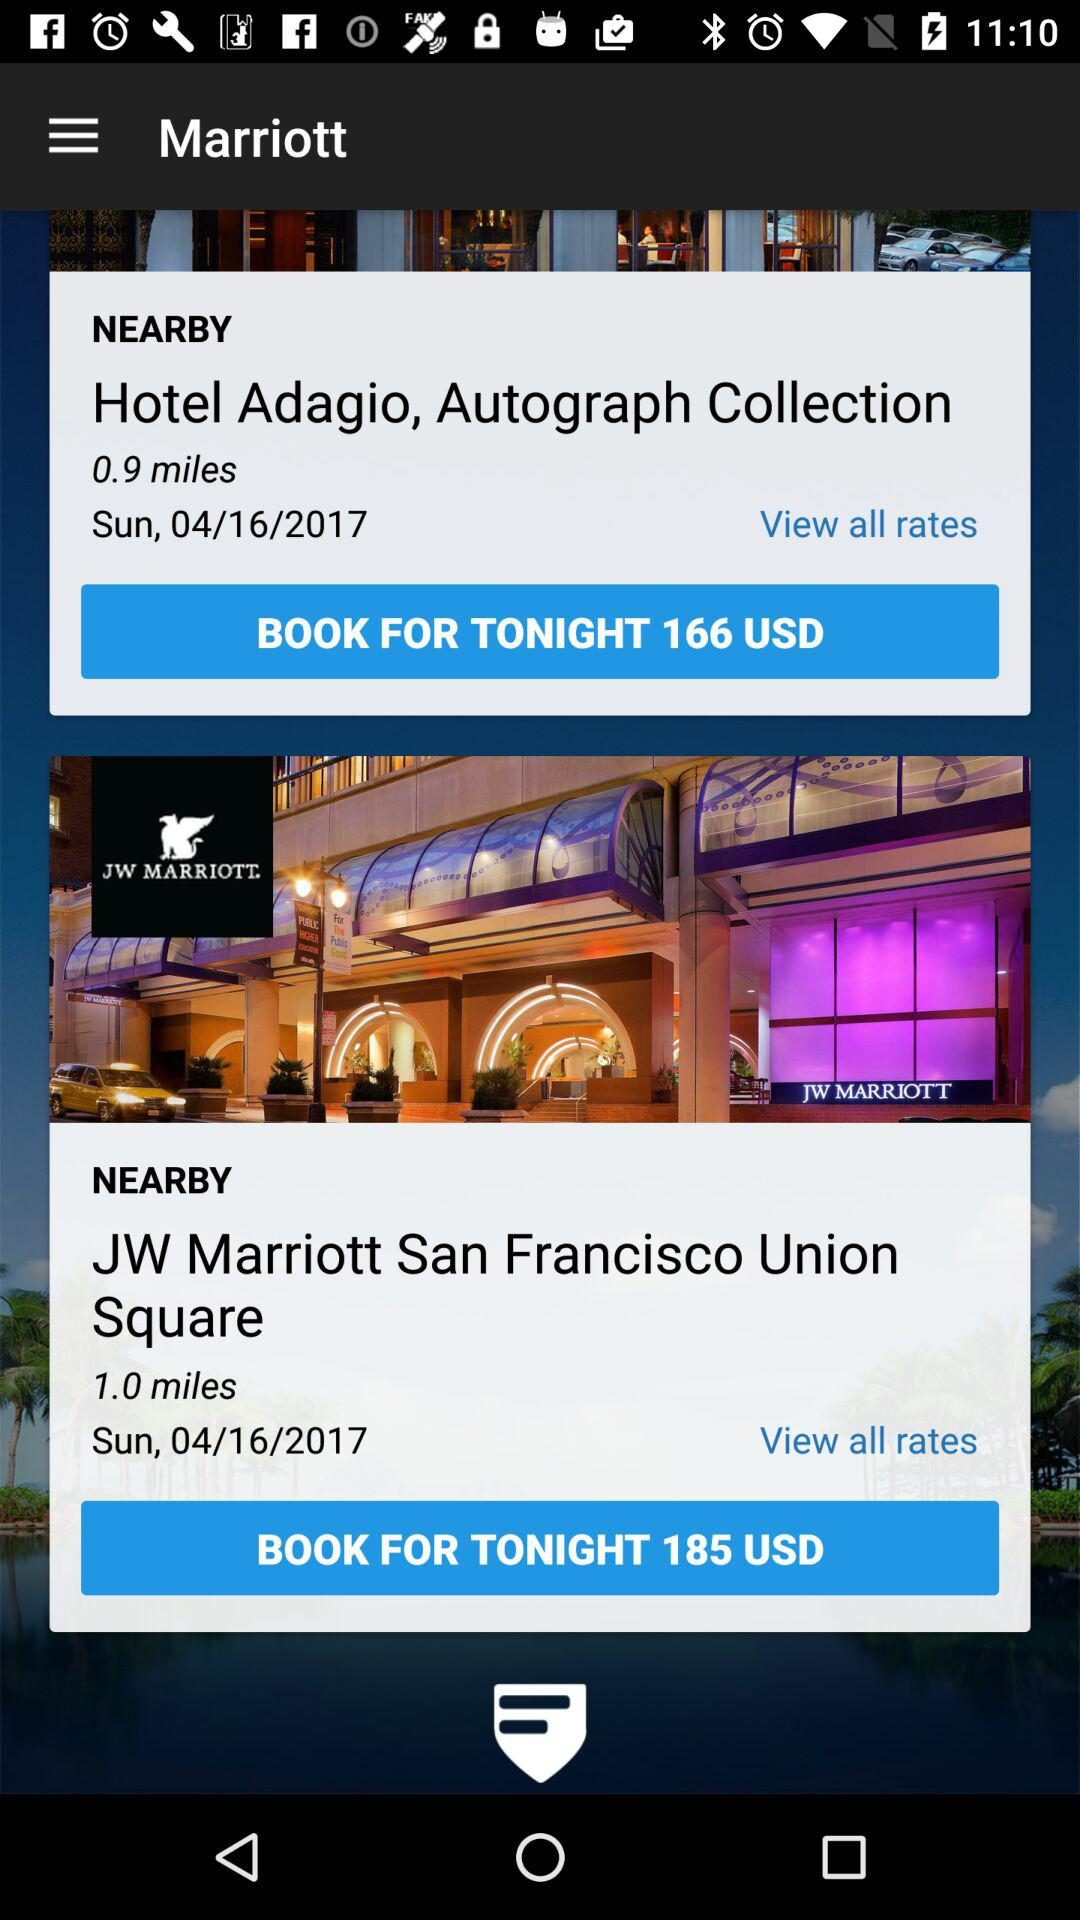For what date is the user finding hotels? The user is finding hotels for Sunday, April 16, 2017. 